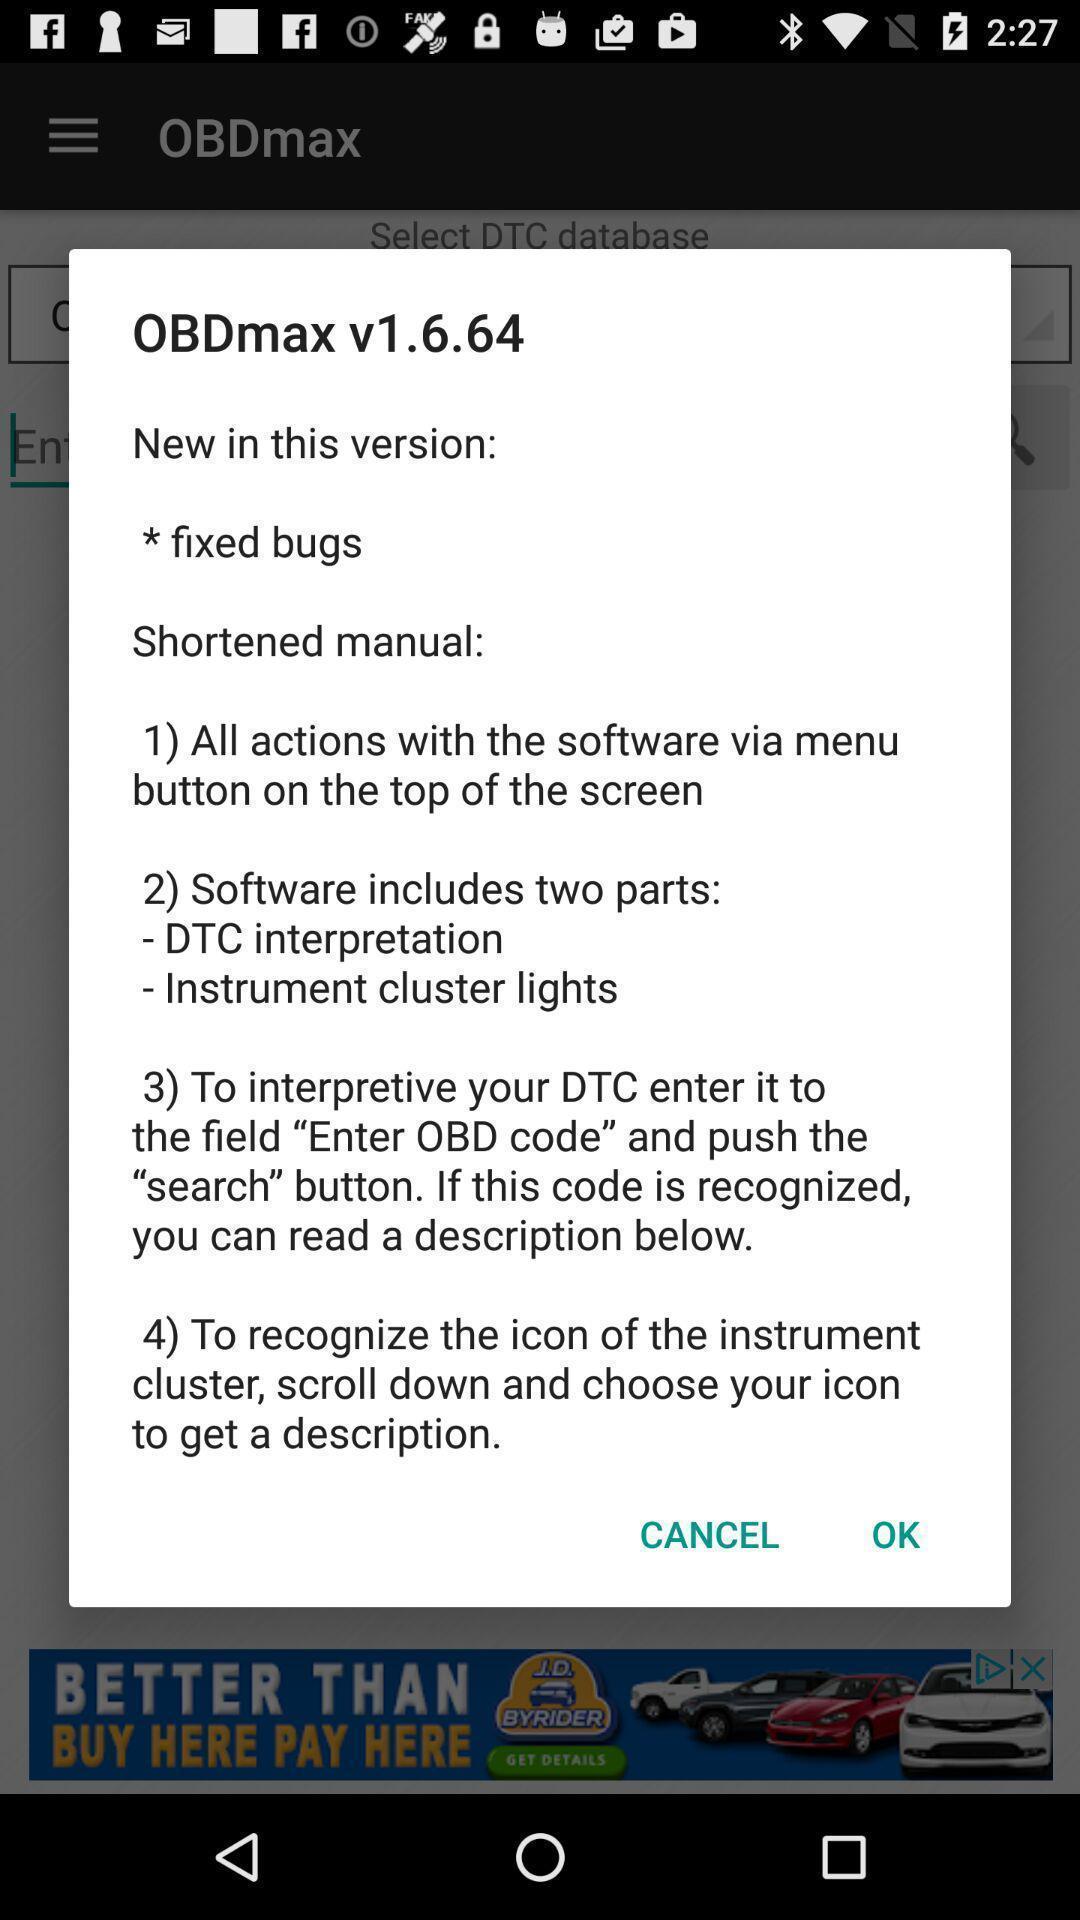Give me a summary of this screen capture. Popup shows information about the vehicle interface app. 